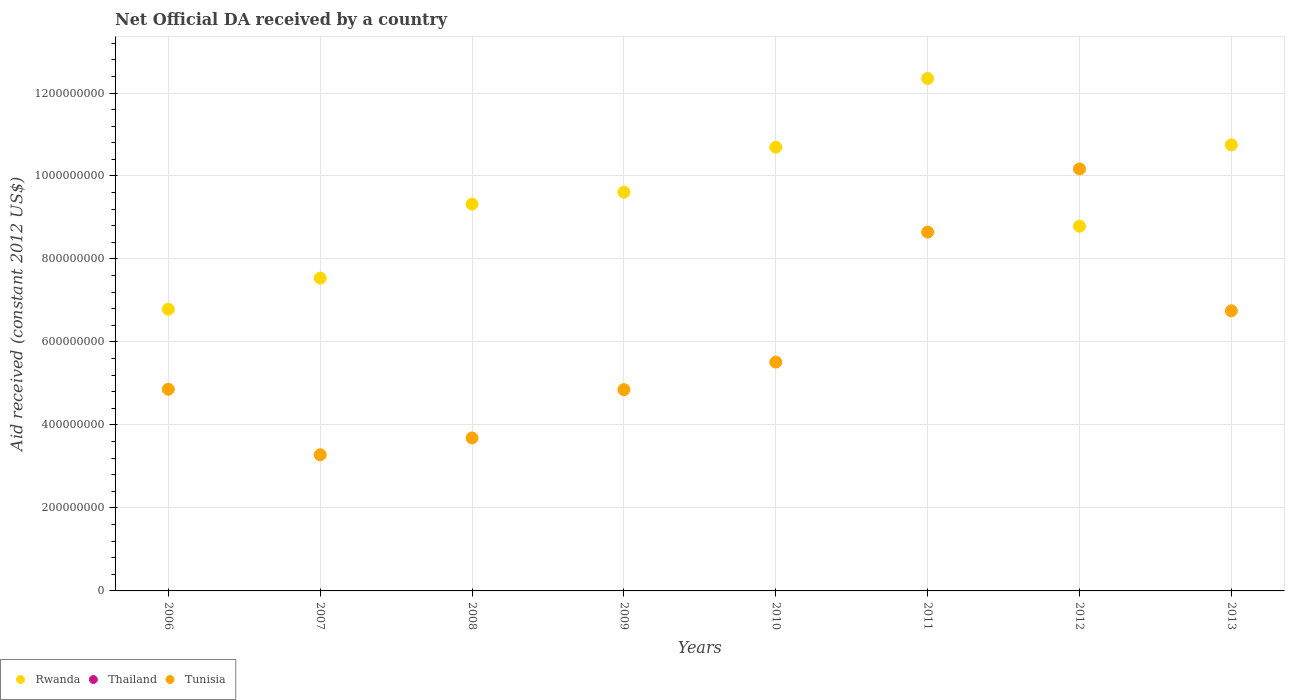Is the number of dotlines equal to the number of legend labels?
Your answer should be very brief. No. What is the net official development assistance aid received in Thailand in 2013?
Provide a succinct answer. 0. Across all years, what is the maximum net official development assistance aid received in Tunisia?
Your response must be concise. 1.02e+09. Across all years, what is the minimum net official development assistance aid received in Rwanda?
Your response must be concise. 6.79e+08. In which year was the net official development assistance aid received in Tunisia maximum?
Keep it short and to the point. 2012. What is the total net official development assistance aid received in Tunisia in the graph?
Provide a succinct answer. 4.78e+09. What is the difference between the net official development assistance aid received in Tunisia in 2008 and that in 2013?
Provide a short and direct response. -3.06e+08. What is the difference between the net official development assistance aid received in Tunisia in 2013 and the net official development assistance aid received in Rwanda in 2007?
Provide a short and direct response. -7.88e+07. What is the average net official development assistance aid received in Tunisia per year?
Your response must be concise. 5.97e+08. In the year 2012, what is the difference between the net official development assistance aid received in Tunisia and net official development assistance aid received in Rwanda?
Offer a very short reply. 1.38e+08. What is the ratio of the net official development assistance aid received in Rwanda in 2006 to that in 2007?
Your answer should be compact. 0.9. Is the net official development assistance aid received in Rwanda in 2007 less than that in 2008?
Ensure brevity in your answer.  Yes. What is the difference between the highest and the second highest net official development assistance aid received in Tunisia?
Offer a terse response. 1.52e+08. What is the difference between the highest and the lowest net official development assistance aid received in Rwanda?
Ensure brevity in your answer.  5.56e+08. Is the sum of the net official development assistance aid received in Rwanda in 2010 and 2011 greater than the maximum net official development assistance aid received in Tunisia across all years?
Your response must be concise. Yes. Is the net official development assistance aid received in Thailand strictly greater than the net official development assistance aid received in Tunisia over the years?
Make the answer very short. No. How many dotlines are there?
Your answer should be compact. 2. Are the values on the major ticks of Y-axis written in scientific E-notation?
Provide a short and direct response. No. Where does the legend appear in the graph?
Offer a very short reply. Bottom left. How many legend labels are there?
Your answer should be compact. 3. How are the legend labels stacked?
Make the answer very short. Horizontal. What is the title of the graph?
Give a very brief answer. Net Official DA received by a country. What is the label or title of the X-axis?
Offer a terse response. Years. What is the label or title of the Y-axis?
Your response must be concise. Aid received (constant 2012 US$). What is the Aid received (constant 2012 US$) of Rwanda in 2006?
Provide a short and direct response. 6.79e+08. What is the Aid received (constant 2012 US$) in Tunisia in 2006?
Give a very brief answer. 4.86e+08. What is the Aid received (constant 2012 US$) of Rwanda in 2007?
Keep it short and to the point. 7.54e+08. What is the Aid received (constant 2012 US$) in Tunisia in 2007?
Your response must be concise. 3.28e+08. What is the Aid received (constant 2012 US$) in Rwanda in 2008?
Keep it short and to the point. 9.32e+08. What is the Aid received (constant 2012 US$) in Tunisia in 2008?
Keep it short and to the point. 3.69e+08. What is the Aid received (constant 2012 US$) of Rwanda in 2009?
Ensure brevity in your answer.  9.61e+08. What is the Aid received (constant 2012 US$) of Tunisia in 2009?
Keep it short and to the point. 4.85e+08. What is the Aid received (constant 2012 US$) of Rwanda in 2010?
Your response must be concise. 1.07e+09. What is the Aid received (constant 2012 US$) of Tunisia in 2010?
Offer a very short reply. 5.51e+08. What is the Aid received (constant 2012 US$) in Rwanda in 2011?
Offer a terse response. 1.24e+09. What is the Aid received (constant 2012 US$) in Tunisia in 2011?
Provide a succinct answer. 8.65e+08. What is the Aid received (constant 2012 US$) of Rwanda in 2012?
Your answer should be compact. 8.79e+08. What is the Aid received (constant 2012 US$) in Thailand in 2012?
Keep it short and to the point. 0. What is the Aid received (constant 2012 US$) of Tunisia in 2012?
Your response must be concise. 1.02e+09. What is the Aid received (constant 2012 US$) in Rwanda in 2013?
Provide a short and direct response. 1.08e+09. What is the Aid received (constant 2012 US$) in Thailand in 2013?
Your response must be concise. 0. What is the Aid received (constant 2012 US$) in Tunisia in 2013?
Your answer should be compact. 6.75e+08. Across all years, what is the maximum Aid received (constant 2012 US$) of Rwanda?
Keep it short and to the point. 1.24e+09. Across all years, what is the maximum Aid received (constant 2012 US$) of Tunisia?
Ensure brevity in your answer.  1.02e+09. Across all years, what is the minimum Aid received (constant 2012 US$) in Rwanda?
Offer a very short reply. 6.79e+08. Across all years, what is the minimum Aid received (constant 2012 US$) in Tunisia?
Make the answer very short. 3.28e+08. What is the total Aid received (constant 2012 US$) of Rwanda in the graph?
Offer a very short reply. 7.58e+09. What is the total Aid received (constant 2012 US$) of Tunisia in the graph?
Your answer should be compact. 4.78e+09. What is the difference between the Aid received (constant 2012 US$) of Rwanda in 2006 and that in 2007?
Keep it short and to the point. -7.50e+07. What is the difference between the Aid received (constant 2012 US$) in Tunisia in 2006 and that in 2007?
Keep it short and to the point. 1.58e+08. What is the difference between the Aid received (constant 2012 US$) of Rwanda in 2006 and that in 2008?
Your answer should be very brief. -2.53e+08. What is the difference between the Aid received (constant 2012 US$) of Tunisia in 2006 and that in 2008?
Ensure brevity in your answer.  1.17e+08. What is the difference between the Aid received (constant 2012 US$) in Rwanda in 2006 and that in 2009?
Give a very brief answer. -2.82e+08. What is the difference between the Aid received (constant 2012 US$) of Tunisia in 2006 and that in 2009?
Provide a short and direct response. 8.30e+05. What is the difference between the Aid received (constant 2012 US$) of Rwanda in 2006 and that in 2010?
Offer a terse response. -3.91e+08. What is the difference between the Aid received (constant 2012 US$) of Tunisia in 2006 and that in 2010?
Offer a terse response. -6.55e+07. What is the difference between the Aid received (constant 2012 US$) of Rwanda in 2006 and that in 2011?
Keep it short and to the point. -5.56e+08. What is the difference between the Aid received (constant 2012 US$) of Tunisia in 2006 and that in 2011?
Provide a succinct answer. -3.79e+08. What is the difference between the Aid received (constant 2012 US$) of Rwanda in 2006 and that in 2012?
Your answer should be very brief. -2.00e+08. What is the difference between the Aid received (constant 2012 US$) in Tunisia in 2006 and that in 2012?
Your answer should be very brief. -5.31e+08. What is the difference between the Aid received (constant 2012 US$) in Rwanda in 2006 and that in 2013?
Give a very brief answer. -3.96e+08. What is the difference between the Aid received (constant 2012 US$) in Tunisia in 2006 and that in 2013?
Offer a very short reply. -1.89e+08. What is the difference between the Aid received (constant 2012 US$) of Rwanda in 2007 and that in 2008?
Make the answer very short. -1.78e+08. What is the difference between the Aid received (constant 2012 US$) in Tunisia in 2007 and that in 2008?
Offer a very short reply. -4.06e+07. What is the difference between the Aid received (constant 2012 US$) in Rwanda in 2007 and that in 2009?
Your answer should be very brief. -2.07e+08. What is the difference between the Aid received (constant 2012 US$) in Tunisia in 2007 and that in 2009?
Your answer should be very brief. -1.57e+08. What is the difference between the Aid received (constant 2012 US$) of Rwanda in 2007 and that in 2010?
Your answer should be compact. -3.16e+08. What is the difference between the Aid received (constant 2012 US$) in Tunisia in 2007 and that in 2010?
Provide a short and direct response. -2.23e+08. What is the difference between the Aid received (constant 2012 US$) of Rwanda in 2007 and that in 2011?
Your answer should be compact. -4.81e+08. What is the difference between the Aid received (constant 2012 US$) of Tunisia in 2007 and that in 2011?
Provide a short and direct response. -5.37e+08. What is the difference between the Aid received (constant 2012 US$) of Rwanda in 2007 and that in 2012?
Keep it short and to the point. -1.25e+08. What is the difference between the Aid received (constant 2012 US$) of Tunisia in 2007 and that in 2012?
Make the answer very short. -6.89e+08. What is the difference between the Aid received (constant 2012 US$) in Rwanda in 2007 and that in 2013?
Provide a succinct answer. -3.21e+08. What is the difference between the Aid received (constant 2012 US$) of Tunisia in 2007 and that in 2013?
Ensure brevity in your answer.  -3.47e+08. What is the difference between the Aid received (constant 2012 US$) of Rwanda in 2008 and that in 2009?
Make the answer very short. -2.90e+07. What is the difference between the Aid received (constant 2012 US$) of Tunisia in 2008 and that in 2009?
Your answer should be compact. -1.16e+08. What is the difference between the Aid received (constant 2012 US$) in Rwanda in 2008 and that in 2010?
Provide a succinct answer. -1.37e+08. What is the difference between the Aid received (constant 2012 US$) of Tunisia in 2008 and that in 2010?
Give a very brief answer. -1.83e+08. What is the difference between the Aid received (constant 2012 US$) of Rwanda in 2008 and that in 2011?
Provide a succinct answer. -3.03e+08. What is the difference between the Aid received (constant 2012 US$) of Tunisia in 2008 and that in 2011?
Provide a short and direct response. -4.96e+08. What is the difference between the Aid received (constant 2012 US$) in Rwanda in 2008 and that in 2012?
Provide a short and direct response. 5.31e+07. What is the difference between the Aid received (constant 2012 US$) of Tunisia in 2008 and that in 2012?
Provide a short and direct response. -6.48e+08. What is the difference between the Aid received (constant 2012 US$) of Rwanda in 2008 and that in 2013?
Offer a very short reply. -1.43e+08. What is the difference between the Aid received (constant 2012 US$) in Tunisia in 2008 and that in 2013?
Offer a very short reply. -3.06e+08. What is the difference between the Aid received (constant 2012 US$) of Rwanda in 2009 and that in 2010?
Provide a short and direct response. -1.08e+08. What is the difference between the Aid received (constant 2012 US$) of Tunisia in 2009 and that in 2010?
Your answer should be compact. -6.64e+07. What is the difference between the Aid received (constant 2012 US$) in Rwanda in 2009 and that in 2011?
Give a very brief answer. -2.74e+08. What is the difference between the Aid received (constant 2012 US$) in Tunisia in 2009 and that in 2011?
Make the answer very short. -3.80e+08. What is the difference between the Aid received (constant 2012 US$) of Rwanda in 2009 and that in 2012?
Provide a succinct answer. 8.21e+07. What is the difference between the Aid received (constant 2012 US$) of Tunisia in 2009 and that in 2012?
Your answer should be compact. -5.32e+08. What is the difference between the Aid received (constant 2012 US$) in Rwanda in 2009 and that in 2013?
Provide a succinct answer. -1.14e+08. What is the difference between the Aid received (constant 2012 US$) in Tunisia in 2009 and that in 2013?
Provide a succinct answer. -1.90e+08. What is the difference between the Aid received (constant 2012 US$) in Rwanda in 2010 and that in 2011?
Make the answer very short. -1.66e+08. What is the difference between the Aid received (constant 2012 US$) in Tunisia in 2010 and that in 2011?
Offer a terse response. -3.13e+08. What is the difference between the Aid received (constant 2012 US$) of Rwanda in 2010 and that in 2012?
Offer a terse response. 1.90e+08. What is the difference between the Aid received (constant 2012 US$) of Tunisia in 2010 and that in 2012?
Give a very brief answer. -4.66e+08. What is the difference between the Aid received (constant 2012 US$) in Rwanda in 2010 and that in 2013?
Provide a succinct answer. -5.61e+06. What is the difference between the Aid received (constant 2012 US$) in Tunisia in 2010 and that in 2013?
Provide a succinct answer. -1.24e+08. What is the difference between the Aid received (constant 2012 US$) of Rwanda in 2011 and that in 2012?
Ensure brevity in your answer.  3.56e+08. What is the difference between the Aid received (constant 2012 US$) in Tunisia in 2011 and that in 2012?
Offer a very short reply. -1.52e+08. What is the difference between the Aid received (constant 2012 US$) in Rwanda in 2011 and that in 2013?
Ensure brevity in your answer.  1.60e+08. What is the difference between the Aid received (constant 2012 US$) in Tunisia in 2011 and that in 2013?
Your answer should be very brief. 1.90e+08. What is the difference between the Aid received (constant 2012 US$) of Rwanda in 2012 and that in 2013?
Keep it short and to the point. -1.96e+08. What is the difference between the Aid received (constant 2012 US$) of Tunisia in 2012 and that in 2013?
Provide a succinct answer. 3.42e+08. What is the difference between the Aid received (constant 2012 US$) of Rwanda in 2006 and the Aid received (constant 2012 US$) of Tunisia in 2007?
Make the answer very short. 3.51e+08. What is the difference between the Aid received (constant 2012 US$) of Rwanda in 2006 and the Aid received (constant 2012 US$) of Tunisia in 2008?
Your response must be concise. 3.10e+08. What is the difference between the Aid received (constant 2012 US$) in Rwanda in 2006 and the Aid received (constant 2012 US$) in Tunisia in 2009?
Offer a terse response. 1.94e+08. What is the difference between the Aid received (constant 2012 US$) of Rwanda in 2006 and the Aid received (constant 2012 US$) of Tunisia in 2010?
Your answer should be very brief. 1.27e+08. What is the difference between the Aid received (constant 2012 US$) in Rwanda in 2006 and the Aid received (constant 2012 US$) in Tunisia in 2011?
Provide a short and direct response. -1.86e+08. What is the difference between the Aid received (constant 2012 US$) in Rwanda in 2006 and the Aid received (constant 2012 US$) in Tunisia in 2012?
Keep it short and to the point. -3.38e+08. What is the difference between the Aid received (constant 2012 US$) of Rwanda in 2006 and the Aid received (constant 2012 US$) of Tunisia in 2013?
Your answer should be very brief. 3.74e+06. What is the difference between the Aid received (constant 2012 US$) in Rwanda in 2007 and the Aid received (constant 2012 US$) in Tunisia in 2008?
Your answer should be compact. 3.85e+08. What is the difference between the Aid received (constant 2012 US$) in Rwanda in 2007 and the Aid received (constant 2012 US$) in Tunisia in 2009?
Your answer should be compact. 2.69e+08. What is the difference between the Aid received (constant 2012 US$) in Rwanda in 2007 and the Aid received (constant 2012 US$) in Tunisia in 2010?
Offer a terse response. 2.02e+08. What is the difference between the Aid received (constant 2012 US$) of Rwanda in 2007 and the Aid received (constant 2012 US$) of Tunisia in 2011?
Offer a very short reply. -1.11e+08. What is the difference between the Aid received (constant 2012 US$) of Rwanda in 2007 and the Aid received (constant 2012 US$) of Tunisia in 2012?
Make the answer very short. -2.63e+08. What is the difference between the Aid received (constant 2012 US$) of Rwanda in 2007 and the Aid received (constant 2012 US$) of Tunisia in 2013?
Offer a terse response. 7.88e+07. What is the difference between the Aid received (constant 2012 US$) in Rwanda in 2008 and the Aid received (constant 2012 US$) in Tunisia in 2009?
Make the answer very short. 4.47e+08. What is the difference between the Aid received (constant 2012 US$) in Rwanda in 2008 and the Aid received (constant 2012 US$) in Tunisia in 2010?
Provide a succinct answer. 3.81e+08. What is the difference between the Aid received (constant 2012 US$) in Rwanda in 2008 and the Aid received (constant 2012 US$) in Tunisia in 2011?
Provide a short and direct response. 6.74e+07. What is the difference between the Aid received (constant 2012 US$) in Rwanda in 2008 and the Aid received (constant 2012 US$) in Tunisia in 2012?
Ensure brevity in your answer.  -8.49e+07. What is the difference between the Aid received (constant 2012 US$) in Rwanda in 2008 and the Aid received (constant 2012 US$) in Tunisia in 2013?
Offer a terse response. 2.57e+08. What is the difference between the Aid received (constant 2012 US$) of Rwanda in 2009 and the Aid received (constant 2012 US$) of Tunisia in 2010?
Your answer should be compact. 4.10e+08. What is the difference between the Aid received (constant 2012 US$) in Rwanda in 2009 and the Aid received (constant 2012 US$) in Tunisia in 2011?
Keep it short and to the point. 9.64e+07. What is the difference between the Aid received (constant 2012 US$) of Rwanda in 2009 and the Aid received (constant 2012 US$) of Tunisia in 2012?
Your response must be concise. -5.59e+07. What is the difference between the Aid received (constant 2012 US$) of Rwanda in 2009 and the Aid received (constant 2012 US$) of Tunisia in 2013?
Offer a very short reply. 2.86e+08. What is the difference between the Aid received (constant 2012 US$) in Rwanda in 2010 and the Aid received (constant 2012 US$) in Tunisia in 2011?
Offer a very short reply. 2.05e+08. What is the difference between the Aid received (constant 2012 US$) of Rwanda in 2010 and the Aid received (constant 2012 US$) of Tunisia in 2012?
Offer a terse response. 5.24e+07. What is the difference between the Aid received (constant 2012 US$) in Rwanda in 2010 and the Aid received (constant 2012 US$) in Tunisia in 2013?
Your answer should be very brief. 3.94e+08. What is the difference between the Aid received (constant 2012 US$) of Rwanda in 2011 and the Aid received (constant 2012 US$) of Tunisia in 2012?
Keep it short and to the point. 2.18e+08. What is the difference between the Aid received (constant 2012 US$) in Rwanda in 2011 and the Aid received (constant 2012 US$) in Tunisia in 2013?
Your response must be concise. 5.60e+08. What is the difference between the Aid received (constant 2012 US$) in Rwanda in 2012 and the Aid received (constant 2012 US$) in Tunisia in 2013?
Provide a succinct answer. 2.04e+08. What is the average Aid received (constant 2012 US$) of Rwanda per year?
Offer a terse response. 9.48e+08. What is the average Aid received (constant 2012 US$) of Tunisia per year?
Ensure brevity in your answer.  5.97e+08. In the year 2006, what is the difference between the Aid received (constant 2012 US$) of Rwanda and Aid received (constant 2012 US$) of Tunisia?
Your response must be concise. 1.93e+08. In the year 2007, what is the difference between the Aid received (constant 2012 US$) in Rwanda and Aid received (constant 2012 US$) in Tunisia?
Give a very brief answer. 4.26e+08. In the year 2008, what is the difference between the Aid received (constant 2012 US$) of Rwanda and Aid received (constant 2012 US$) of Tunisia?
Offer a terse response. 5.63e+08. In the year 2009, what is the difference between the Aid received (constant 2012 US$) of Rwanda and Aid received (constant 2012 US$) of Tunisia?
Give a very brief answer. 4.76e+08. In the year 2010, what is the difference between the Aid received (constant 2012 US$) of Rwanda and Aid received (constant 2012 US$) of Tunisia?
Offer a terse response. 5.18e+08. In the year 2011, what is the difference between the Aid received (constant 2012 US$) of Rwanda and Aid received (constant 2012 US$) of Tunisia?
Make the answer very short. 3.70e+08. In the year 2012, what is the difference between the Aid received (constant 2012 US$) of Rwanda and Aid received (constant 2012 US$) of Tunisia?
Offer a terse response. -1.38e+08. In the year 2013, what is the difference between the Aid received (constant 2012 US$) in Rwanda and Aid received (constant 2012 US$) in Tunisia?
Keep it short and to the point. 4.00e+08. What is the ratio of the Aid received (constant 2012 US$) of Rwanda in 2006 to that in 2007?
Your answer should be compact. 0.9. What is the ratio of the Aid received (constant 2012 US$) in Tunisia in 2006 to that in 2007?
Your answer should be compact. 1.48. What is the ratio of the Aid received (constant 2012 US$) in Rwanda in 2006 to that in 2008?
Keep it short and to the point. 0.73. What is the ratio of the Aid received (constant 2012 US$) of Tunisia in 2006 to that in 2008?
Give a very brief answer. 1.32. What is the ratio of the Aid received (constant 2012 US$) in Rwanda in 2006 to that in 2009?
Your answer should be very brief. 0.71. What is the ratio of the Aid received (constant 2012 US$) in Tunisia in 2006 to that in 2009?
Give a very brief answer. 1. What is the ratio of the Aid received (constant 2012 US$) of Rwanda in 2006 to that in 2010?
Offer a very short reply. 0.63. What is the ratio of the Aid received (constant 2012 US$) of Tunisia in 2006 to that in 2010?
Your response must be concise. 0.88. What is the ratio of the Aid received (constant 2012 US$) of Rwanda in 2006 to that in 2011?
Provide a succinct answer. 0.55. What is the ratio of the Aid received (constant 2012 US$) in Tunisia in 2006 to that in 2011?
Keep it short and to the point. 0.56. What is the ratio of the Aid received (constant 2012 US$) of Rwanda in 2006 to that in 2012?
Offer a very short reply. 0.77. What is the ratio of the Aid received (constant 2012 US$) in Tunisia in 2006 to that in 2012?
Provide a succinct answer. 0.48. What is the ratio of the Aid received (constant 2012 US$) in Rwanda in 2006 to that in 2013?
Make the answer very short. 0.63. What is the ratio of the Aid received (constant 2012 US$) of Tunisia in 2006 to that in 2013?
Keep it short and to the point. 0.72. What is the ratio of the Aid received (constant 2012 US$) in Rwanda in 2007 to that in 2008?
Make the answer very short. 0.81. What is the ratio of the Aid received (constant 2012 US$) of Tunisia in 2007 to that in 2008?
Offer a terse response. 0.89. What is the ratio of the Aid received (constant 2012 US$) of Rwanda in 2007 to that in 2009?
Make the answer very short. 0.78. What is the ratio of the Aid received (constant 2012 US$) of Tunisia in 2007 to that in 2009?
Offer a terse response. 0.68. What is the ratio of the Aid received (constant 2012 US$) of Rwanda in 2007 to that in 2010?
Ensure brevity in your answer.  0.7. What is the ratio of the Aid received (constant 2012 US$) of Tunisia in 2007 to that in 2010?
Ensure brevity in your answer.  0.59. What is the ratio of the Aid received (constant 2012 US$) of Rwanda in 2007 to that in 2011?
Your response must be concise. 0.61. What is the ratio of the Aid received (constant 2012 US$) of Tunisia in 2007 to that in 2011?
Your answer should be very brief. 0.38. What is the ratio of the Aid received (constant 2012 US$) of Rwanda in 2007 to that in 2012?
Your answer should be compact. 0.86. What is the ratio of the Aid received (constant 2012 US$) in Tunisia in 2007 to that in 2012?
Ensure brevity in your answer.  0.32. What is the ratio of the Aid received (constant 2012 US$) in Rwanda in 2007 to that in 2013?
Make the answer very short. 0.7. What is the ratio of the Aid received (constant 2012 US$) in Tunisia in 2007 to that in 2013?
Offer a very short reply. 0.49. What is the ratio of the Aid received (constant 2012 US$) of Rwanda in 2008 to that in 2009?
Your response must be concise. 0.97. What is the ratio of the Aid received (constant 2012 US$) in Tunisia in 2008 to that in 2009?
Offer a terse response. 0.76. What is the ratio of the Aid received (constant 2012 US$) of Rwanda in 2008 to that in 2010?
Offer a very short reply. 0.87. What is the ratio of the Aid received (constant 2012 US$) of Tunisia in 2008 to that in 2010?
Your response must be concise. 0.67. What is the ratio of the Aid received (constant 2012 US$) of Rwanda in 2008 to that in 2011?
Your answer should be compact. 0.75. What is the ratio of the Aid received (constant 2012 US$) of Tunisia in 2008 to that in 2011?
Your answer should be very brief. 0.43. What is the ratio of the Aid received (constant 2012 US$) of Rwanda in 2008 to that in 2012?
Make the answer very short. 1.06. What is the ratio of the Aid received (constant 2012 US$) in Tunisia in 2008 to that in 2012?
Ensure brevity in your answer.  0.36. What is the ratio of the Aid received (constant 2012 US$) in Rwanda in 2008 to that in 2013?
Give a very brief answer. 0.87. What is the ratio of the Aid received (constant 2012 US$) of Tunisia in 2008 to that in 2013?
Offer a terse response. 0.55. What is the ratio of the Aid received (constant 2012 US$) in Rwanda in 2009 to that in 2010?
Offer a very short reply. 0.9. What is the ratio of the Aid received (constant 2012 US$) of Tunisia in 2009 to that in 2010?
Give a very brief answer. 0.88. What is the ratio of the Aid received (constant 2012 US$) of Rwanda in 2009 to that in 2011?
Provide a short and direct response. 0.78. What is the ratio of the Aid received (constant 2012 US$) in Tunisia in 2009 to that in 2011?
Your answer should be compact. 0.56. What is the ratio of the Aid received (constant 2012 US$) in Rwanda in 2009 to that in 2012?
Ensure brevity in your answer.  1.09. What is the ratio of the Aid received (constant 2012 US$) in Tunisia in 2009 to that in 2012?
Your answer should be very brief. 0.48. What is the ratio of the Aid received (constant 2012 US$) in Rwanda in 2009 to that in 2013?
Ensure brevity in your answer.  0.89. What is the ratio of the Aid received (constant 2012 US$) of Tunisia in 2009 to that in 2013?
Ensure brevity in your answer.  0.72. What is the ratio of the Aid received (constant 2012 US$) of Rwanda in 2010 to that in 2011?
Your answer should be very brief. 0.87. What is the ratio of the Aid received (constant 2012 US$) in Tunisia in 2010 to that in 2011?
Your response must be concise. 0.64. What is the ratio of the Aid received (constant 2012 US$) in Rwanda in 2010 to that in 2012?
Offer a terse response. 1.22. What is the ratio of the Aid received (constant 2012 US$) of Tunisia in 2010 to that in 2012?
Your response must be concise. 0.54. What is the ratio of the Aid received (constant 2012 US$) in Rwanda in 2010 to that in 2013?
Offer a terse response. 0.99. What is the ratio of the Aid received (constant 2012 US$) in Tunisia in 2010 to that in 2013?
Your answer should be very brief. 0.82. What is the ratio of the Aid received (constant 2012 US$) in Rwanda in 2011 to that in 2012?
Make the answer very short. 1.41. What is the ratio of the Aid received (constant 2012 US$) of Tunisia in 2011 to that in 2012?
Ensure brevity in your answer.  0.85. What is the ratio of the Aid received (constant 2012 US$) in Rwanda in 2011 to that in 2013?
Keep it short and to the point. 1.15. What is the ratio of the Aid received (constant 2012 US$) of Tunisia in 2011 to that in 2013?
Your response must be concise. 1.28. What is the ratio of the Aid received (constant 2012 US$) of Rwanda in 2012 to that in 2013?
Ensure brevity in your answer.  0.82. What is the ratio of the Aid received (constant 2012 US$) in Tunisia in 2012 to that in 2013?
Your answer should be compact. 1.51. What is the difference between the highest and the second highest Aid received (constant 2012 US$) of Rwanda?
Your response must be concise. 1.60e+08. What is the difference between the highest and the second highest Aid received (constant 2012 US$) in Tunisia?
Your answer should be very brief. 1.52e+08. What is the difference between the highest and the lowest Aid received (constant 2012 US$) in Rwanda?
Provide a succinct answer. 5.56e+08. What is the difference between the highest and the lowest Aid received (constant 2012 US$) in Tunisia?
Your response must be concise. 6.89e+08. 